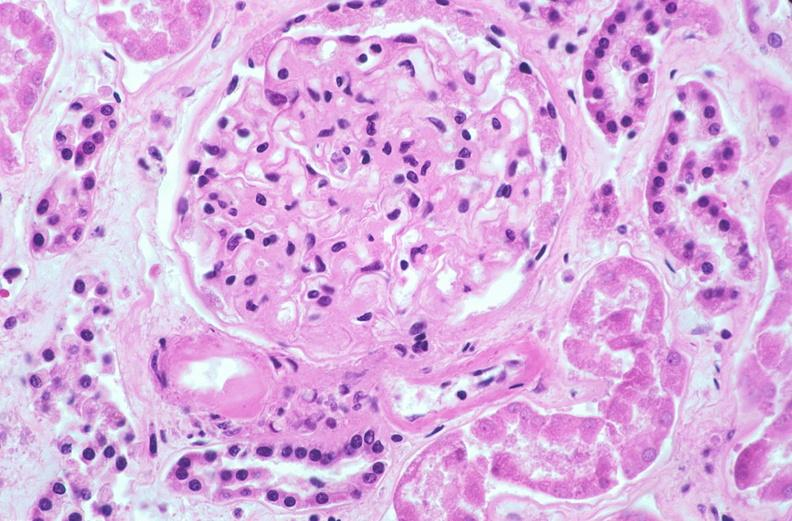what does this image show?
Answer the question using a single word or phrase. Kidney glomerulus 